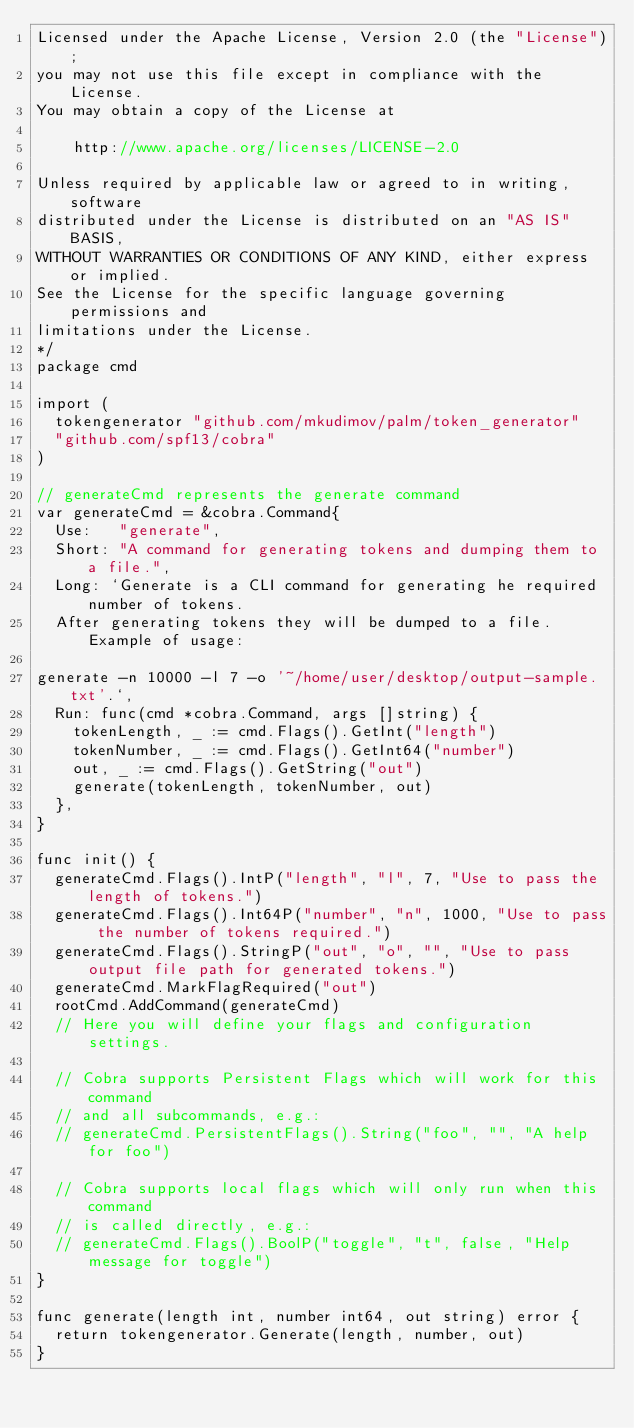<code> <loc_0><loc_0><loc_500><loc_500><_Go_>Licensed under the Apache License, Version 2.0 (the "License");
you may not use this file except in compliance with the License.
You may obtain a copy of the License at

    http://www.apache.org/licenses/LICENSE-2.0

Unless required by applicable law or agreed to in writing, software
distributed under the License is distributed on an "AS IS" BASIS,
WITHOUT WARRANTIES OR CONDITIONS OF ANY KIND, either express or implied.
See the License for the specific language governing permissions and
limitations under the License.
*/
package cmd

import (
	tokengenerator "github.com/mkudimov/palm/token_generator"
	"github.com/spf13/cobra"
)

// generateCmd represents the generate command
var generateCmd = &cobra.Command{
	Use:   "generate",
	Short: "A command for generating tokens and dumping them to a file.",
	Long: `Generate is a CLI command for generating he required number of tokens. 
	After generating tokens they will be dumped to a file. Example of usage:

generate -n 10000 -l 7 -o '~/home/user/desktop/output-sample.txt'.`,
	Run: func(cmd *cobra.Command, args []string) {
		tokenLength, _ := cmd.Flags().GetInt("length")
		tokenNumber, _ := cmd.Flags().GetInt64("number")
		out, _ := cmd.Flags().GetString("out")
		generate(tokenLength, tokenNumber, out)
	},
}

func init() {
	generateCmd.Flags().IntP("length", "l", 7, "Use to pass the length of tokens.")
	generateCmd.Flags().Int64P("number", "n", 1000, "Use to pass the number of tokens required.")
	generateCmd.Flags().StringP("out", "o", "", "Use to pass output file path for generated tokens.")
	generateCmd.MarkFlagRequired("out")
	rootCmd.AddCommand(generateCmd)
	// Here you will define your flags and configuration settings.

	// Cobra supports Persistent Flags which will work for this command
	// and all subcommands, e.g.:
	// generateCmd.PersistentFlags().String("foo", "", "A help for foo")

	// Cobra supports local flags which will only run when this command
	// is called directly, e.g.:
	// generateCmd.Flags().BoolP("toggle", "t", false, "Help message for toggle")
}

func generate(length int, number int64, out string) error {
	return tokengenerator.Generate(length, number, out)
}
</code> 